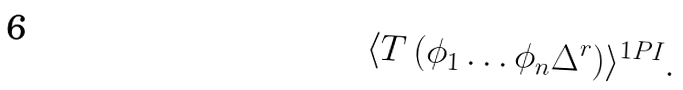<formula> <loc_0><loc_0><loc_500><loc_500>\langle T \left ( \phi _ { 1 } \dots \phi _ { n } \Delta ^ { r } \right ) \rangle ^ { 1 P I } .</formula> 